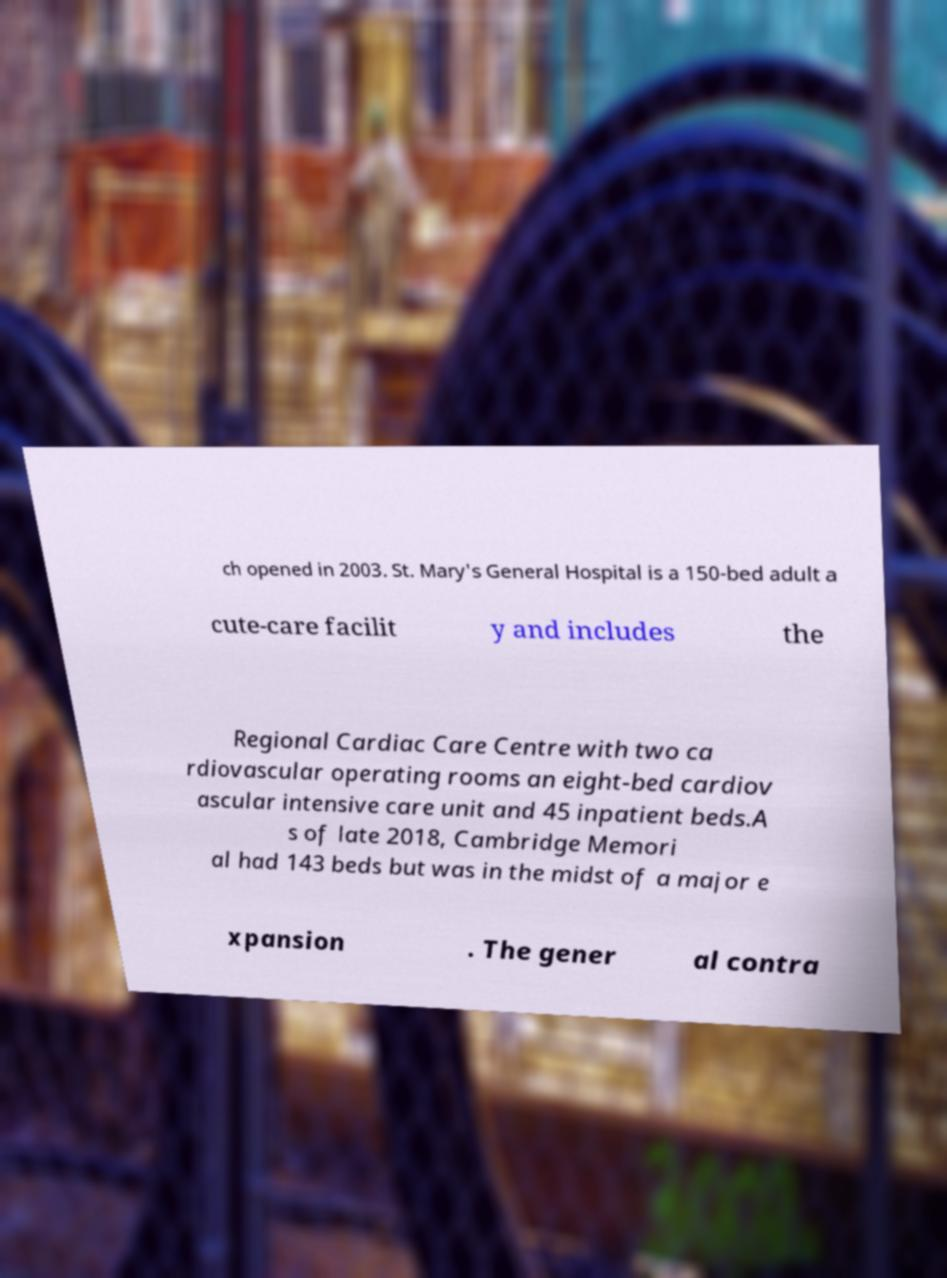There's text embedded in this image that I need extracted. Can you transcribe it verbatim? ch opened in 2003. St. Mary's General Hospital is a 150-bed adult a cute-care facilit y and includes the Regional Cardiac Care Centre with two ca rdiovascular operating rooms an eight-bed cardiov ascular intensive care unit and 45 inpatient beds.A s of late 2018, Cambridge Memori al had 143 beds but was in the midst of a major e xpansion . The gener al contra 